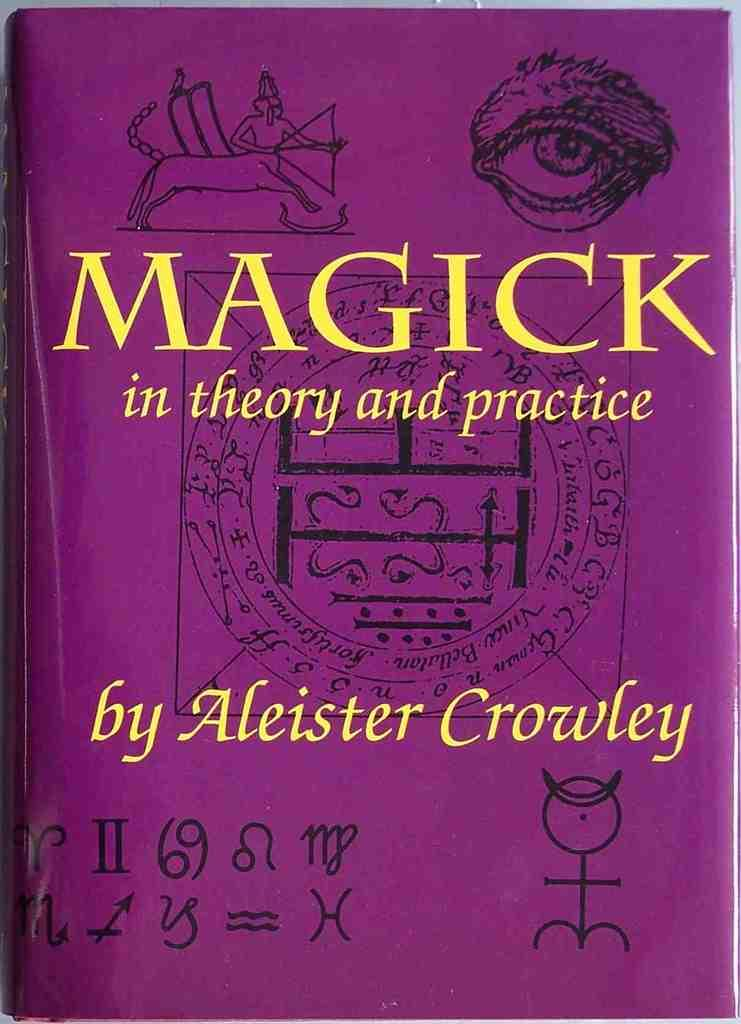<image>
Offer a succinct explanation of the picture presented. A copy of the book Magick by Aleister Crowley. 